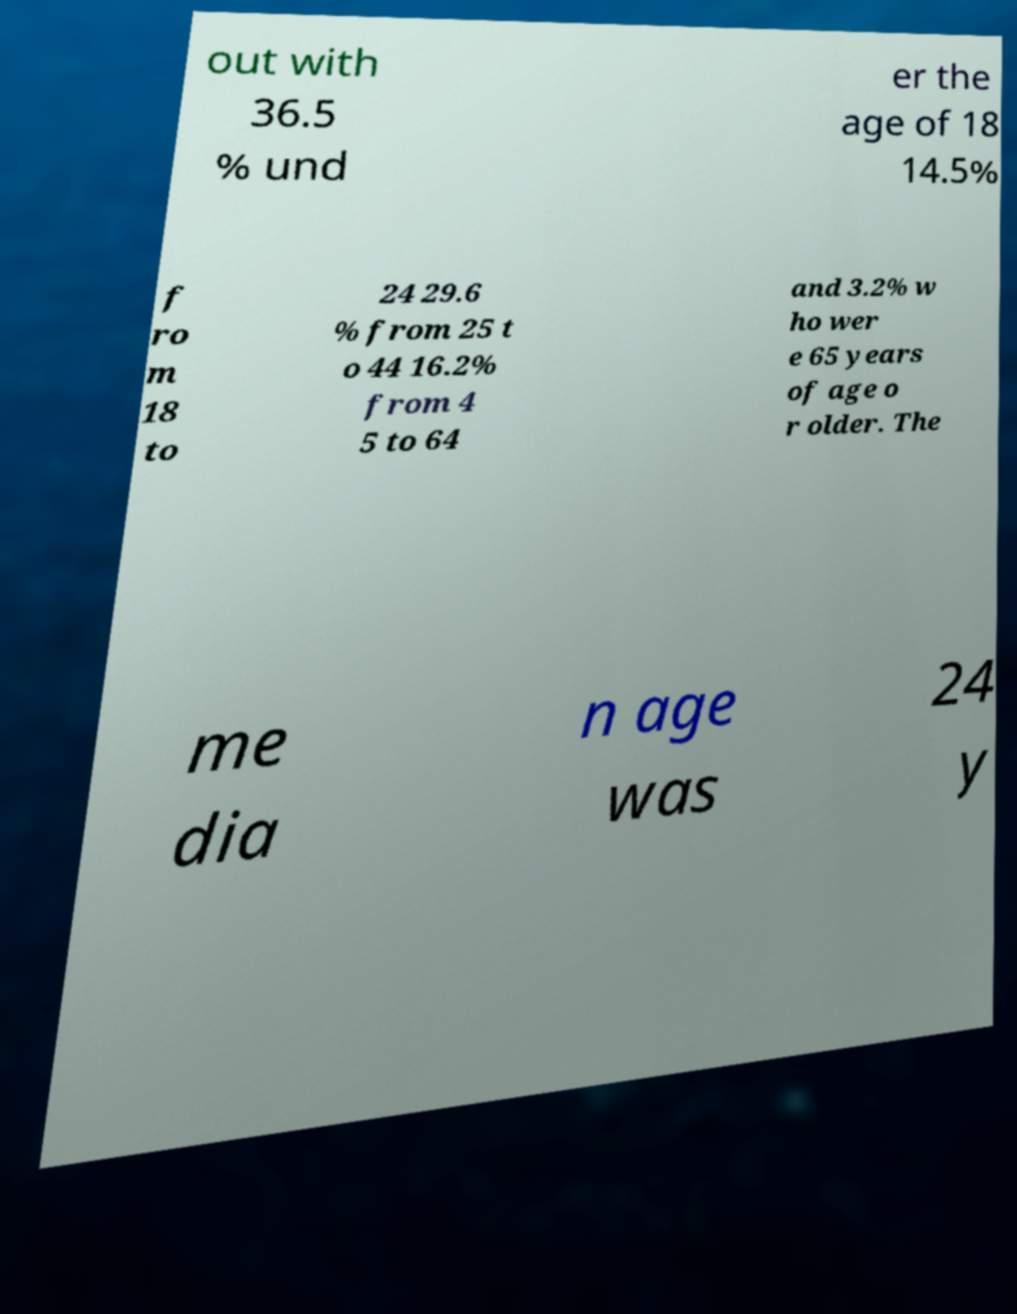What messages or text are displayed in this image? I need them in a readable, typed format. out with 36.5 % und er the age of 18 14.5% f ro m 18 to 24 29.6 % from 25 t o 44 16.2% from 4 5 to 64 and 3.2% w ho wer e 65 years of age o r older. The me dia n age was 24 y 